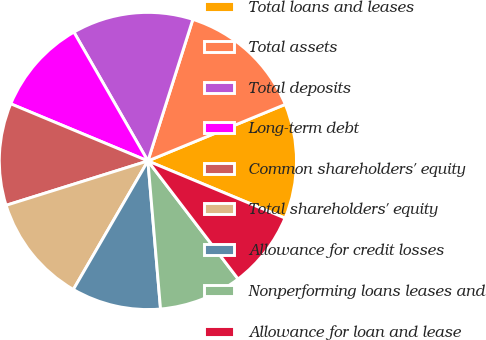<chart> <loc_0><loc_0><loc_500><loc_500><pie_chart><fcel>Total loans and leases<fcel>Total assets<fcel>Total deposits<fcel>Long-term debt<fcel>Common shareholders' equity<fcel>Total shareholders' equity<fcel>Allowance for credit losses<fcel>Nonperforming loans leases and<fcel>Allowance for loan and lease<nl><fcel>12.5%<fcel>13.89%<fcel>13.19%<fcel>10.42%<fcel>11.11%<fcel>11.81%<fcel>9.72%<fcel>9.03%<fcel>8.33%<nl></chart> 